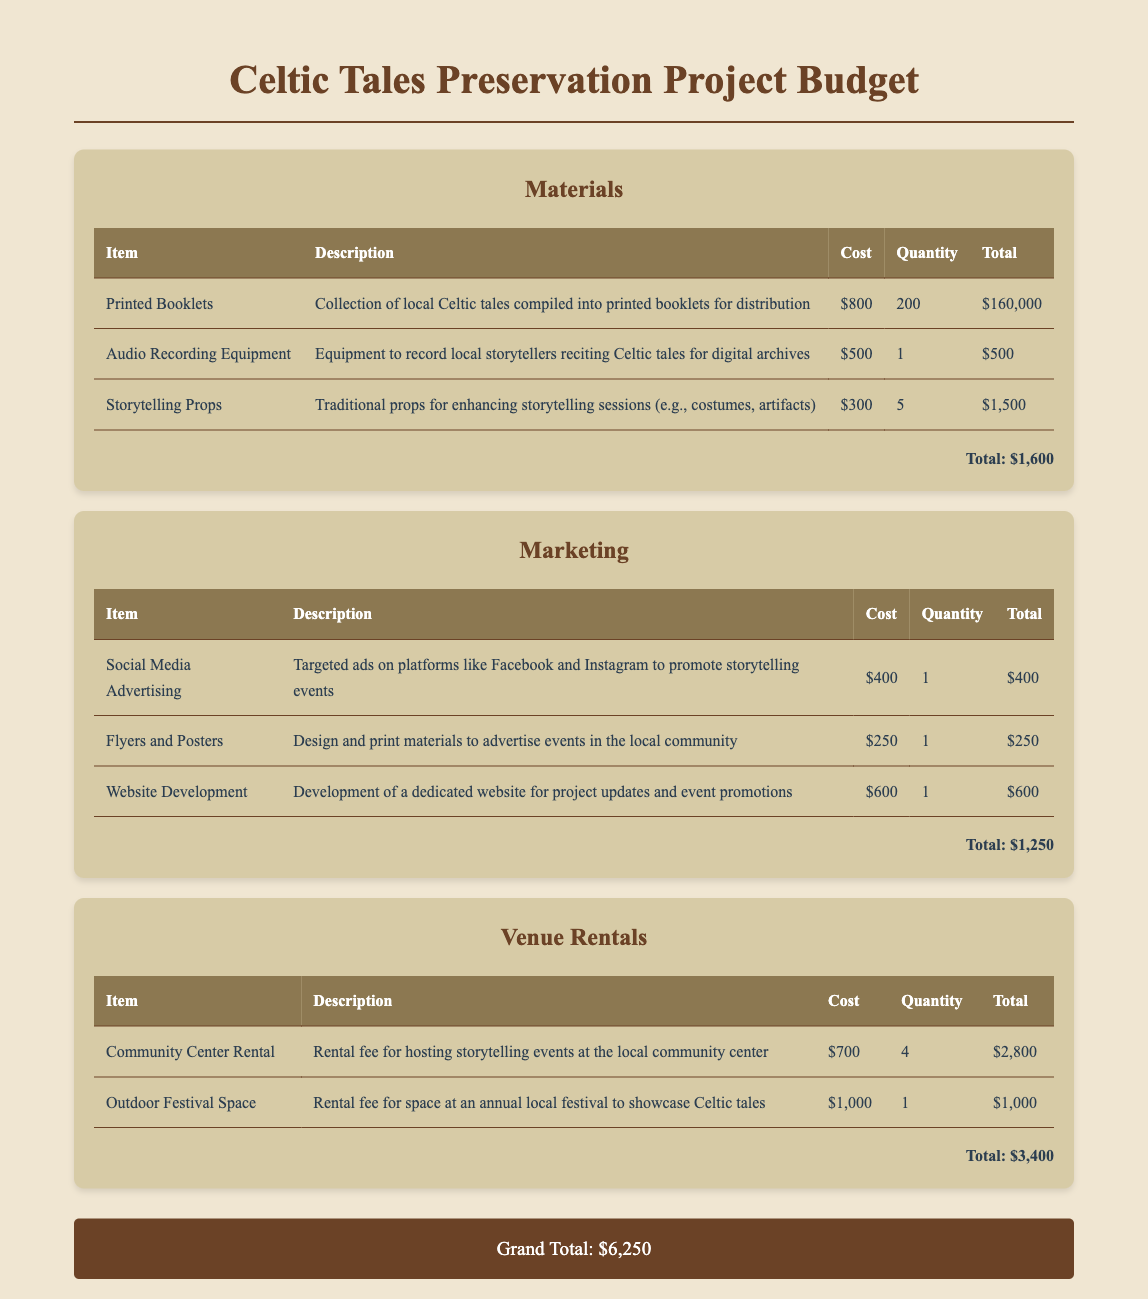What is the total cost for materials? The total cost for materials is stated at the end of the Materials section, which adds up to $1,600.
Answer: $1,600 How many printed booklets are planned for distribution? The quantity of printed booklets listed in the document is 200.
Answer: 200 What is the cost of the social media advertising? The cost for social media advertising is mentioned as $400 in the Marketing section.
Answer: $400 What is the total cost for venue rentals? The total cost for venue rentals is provided at the end of the Venue Rentals section, which is $3,400.
Answer: $3,400 What is the grand total for the project? The grand total for the project is listed at the bottom of the document as $6,250.
Answer: $6,250 How many storytelling sessions can be held at the community center? The community center rental fee is for 4 sessions as stated in the document.
Answer: 4 What equipment is included in the budget for audio recording? The document mentions “Audio Recording Equipment” which costs $500.
Answer: Audio Recording Equipment Which category has the highest total cost? Venue Rentals has the highest total cost of $3,400 compared to the other categories.
Answer: Venue Rentals 